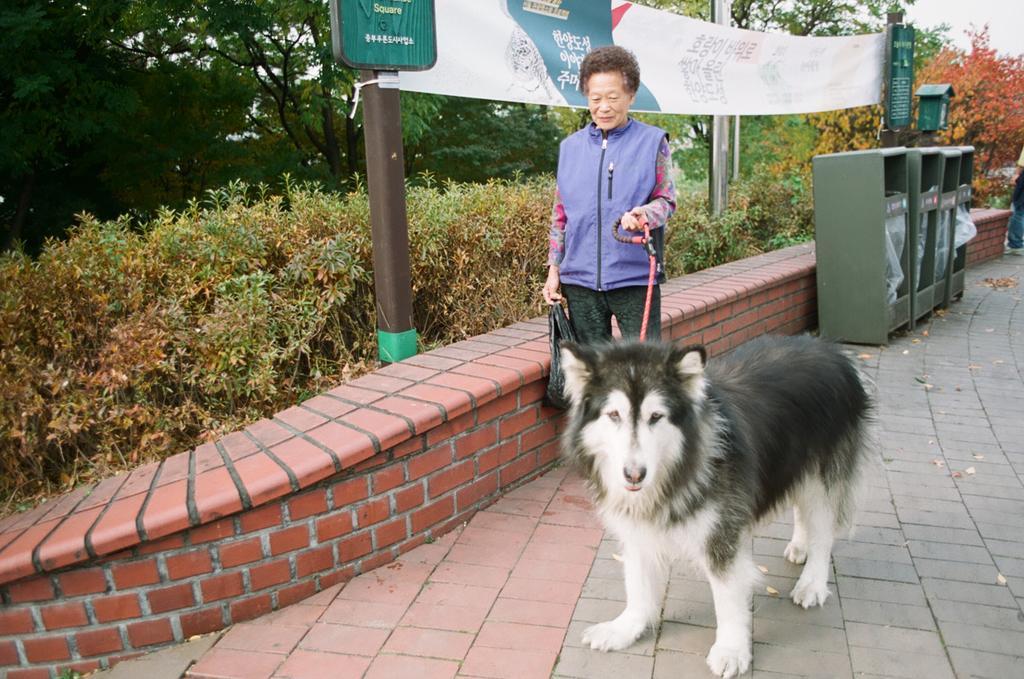Could you give a brief overview of what you see in this image? In this picture we can see a woman is holding a dog belt and in front of the woman there is a dog. Behind the woman there is a wall, poles, banner, trees and a sky. 